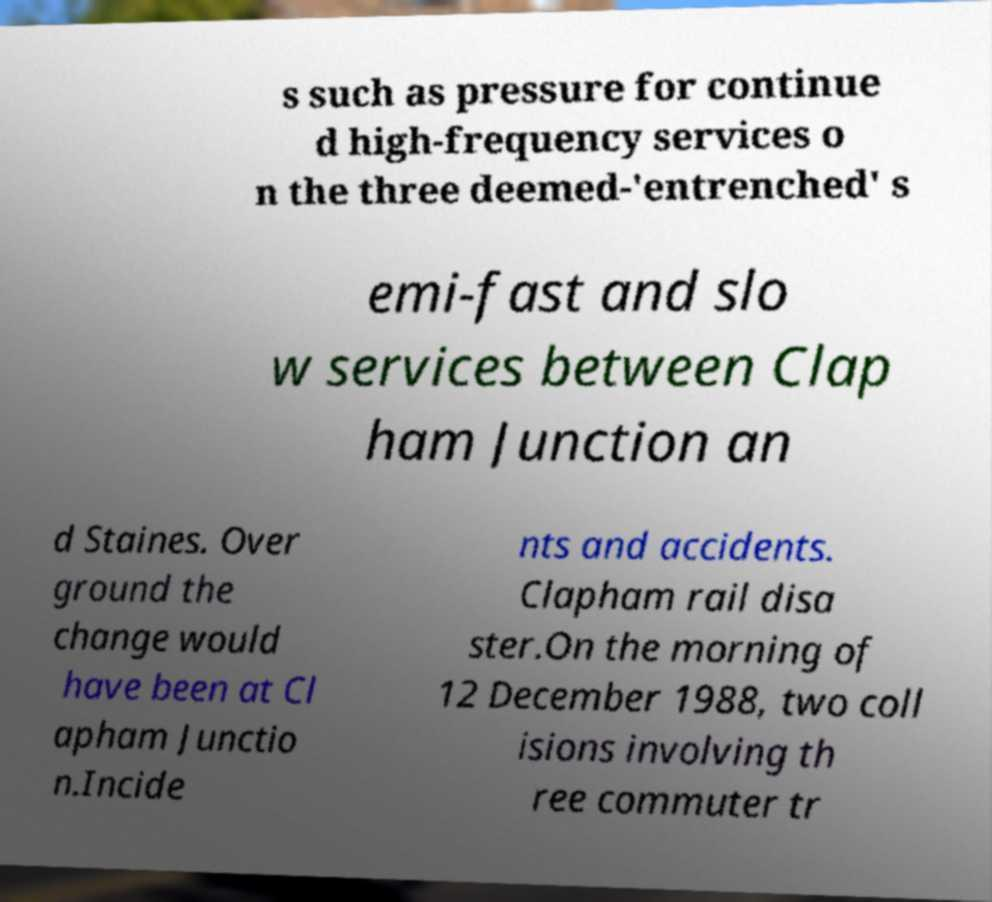There's text embedded in this image that I need extracted. Can you transcribe it verbatim? s such as pressure for continue d high-frequency services o n the three deemed-'entrenched' s emi-fast and slo w services between Clap ham Junction an d Staines. Over ground the change would have been at Cl apham Junctio n.Incide nts and accidents. Clapham rail disa ster.On the morning of 12 December 1988, two coll isions involving th ree commuter tr 